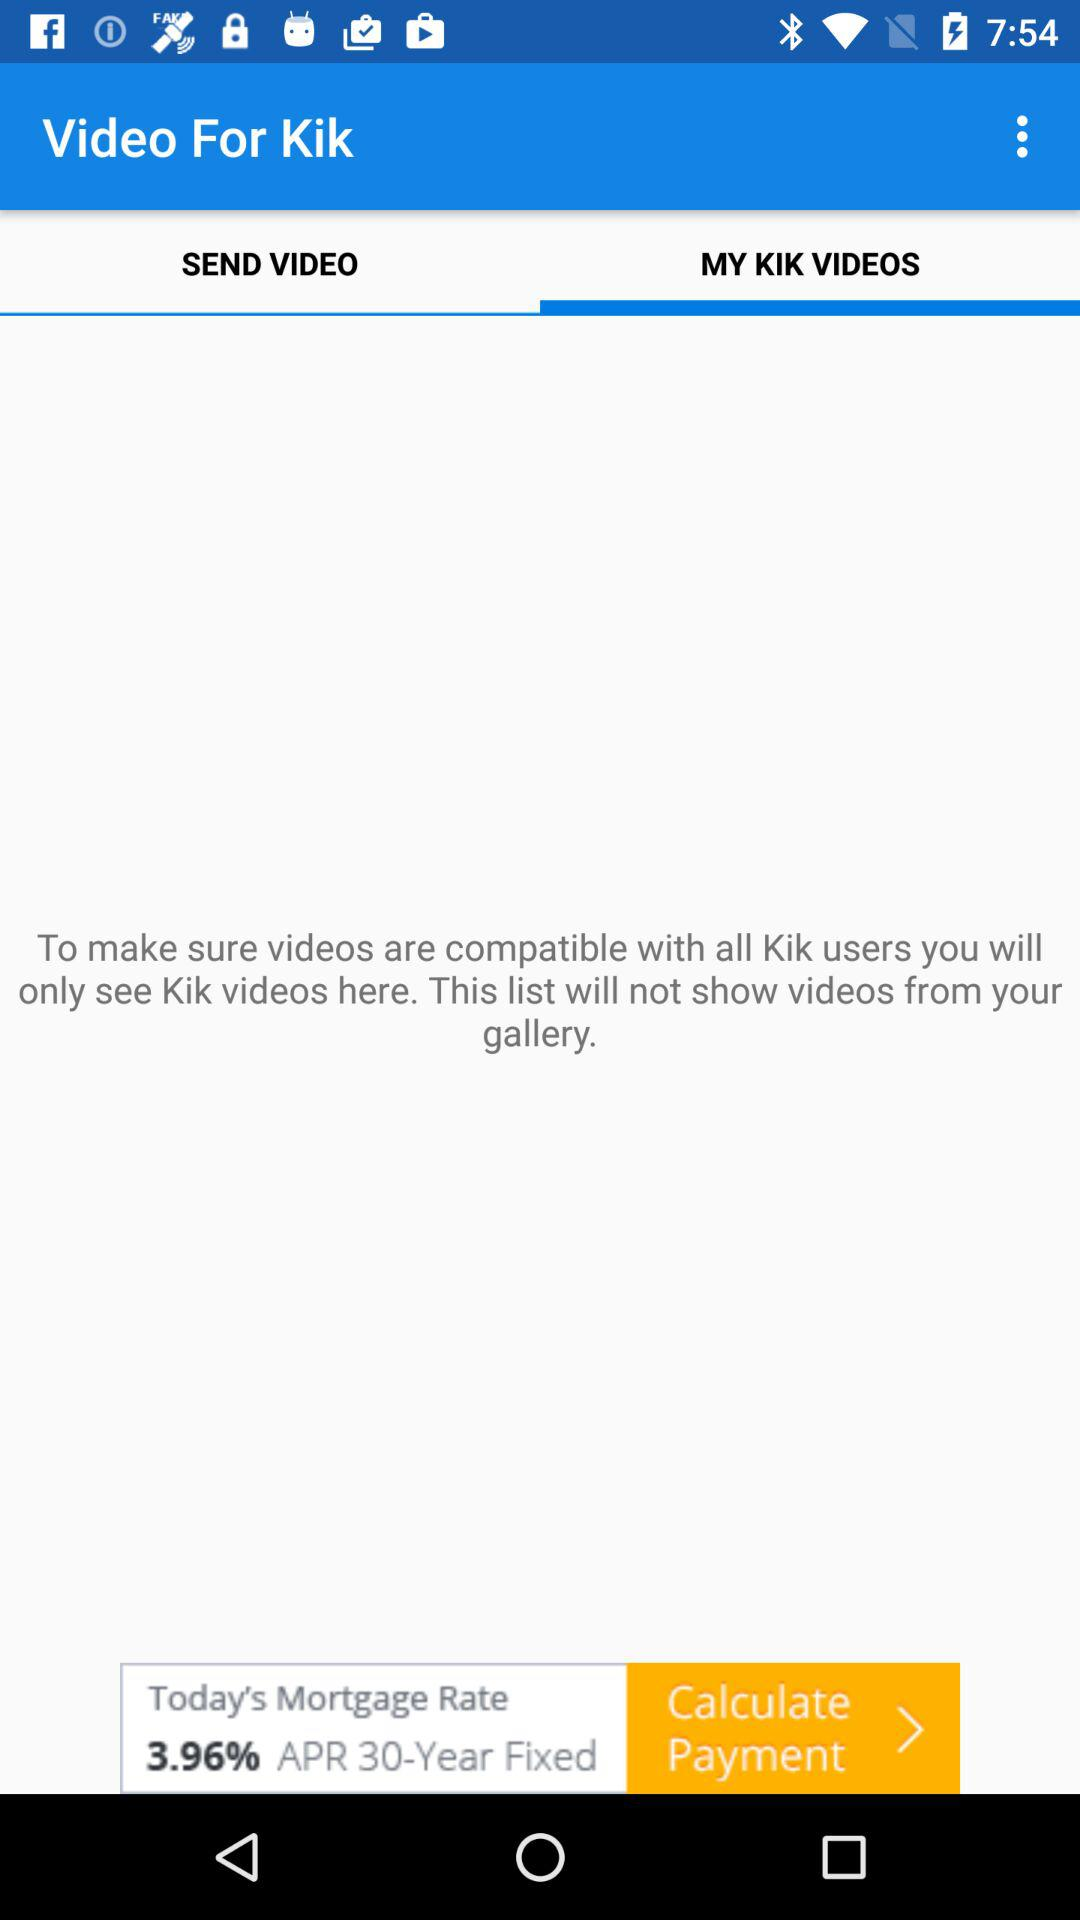Which tab is selected? The selected tab is "MY KIK VIDEOS". 